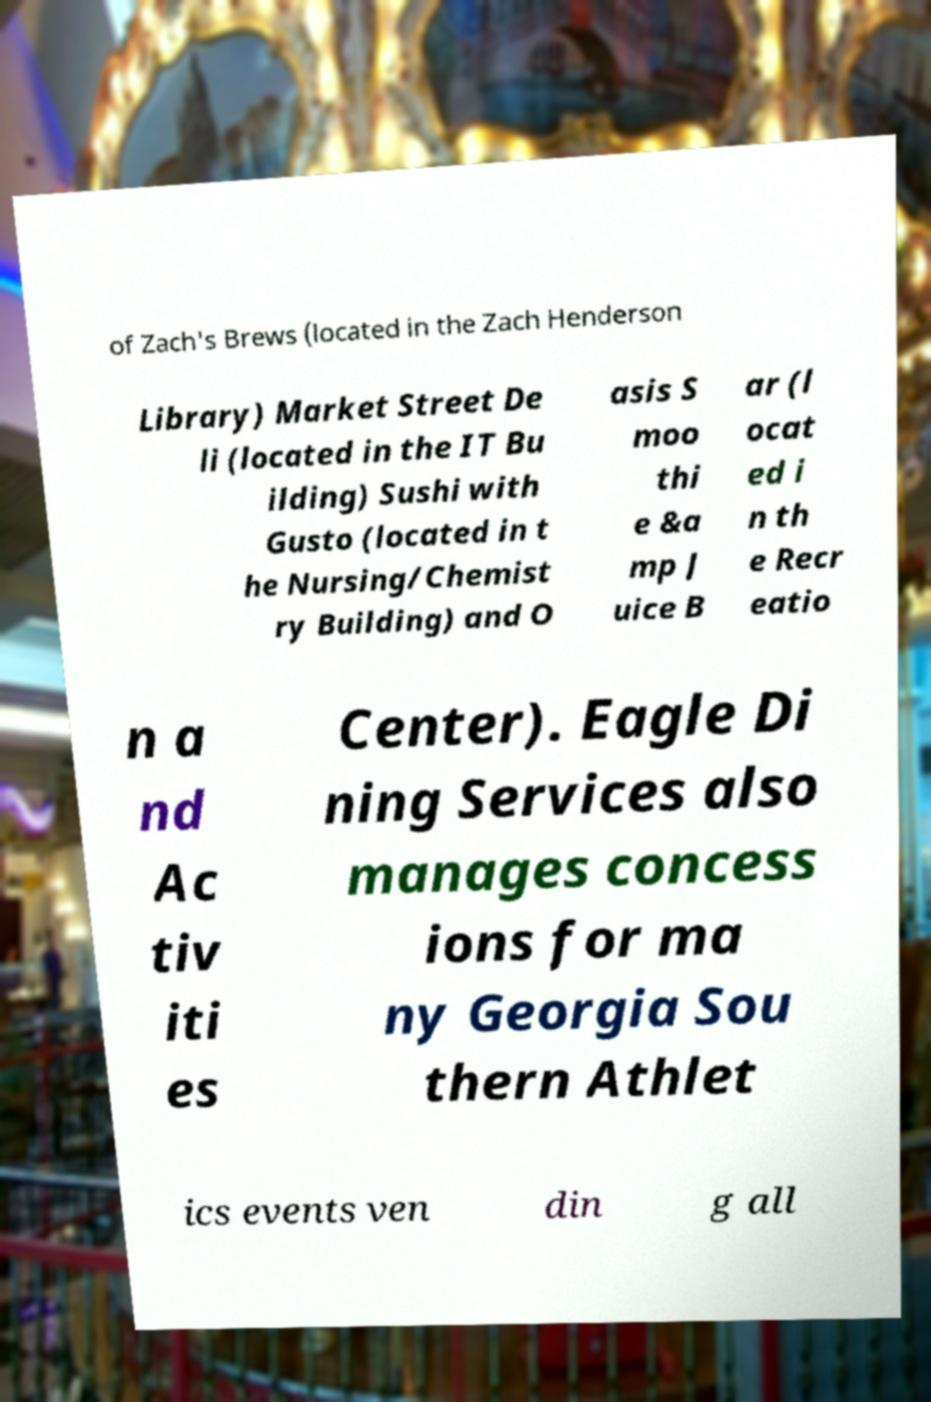Could you assist in decoding the text presented in this image and type it out clearly? of Zach's Brews (located in the Zach Henderson Library) Market Street De li (located in the IT Bu ilding) Sushi with Gusto (located in t he Nursing/Chemist ry Building) and O asis S moo thi e &a mp J uice B ar (l ocat ed i n th e Recr eatio n a nd Ac tiv iti es Center). Eagle Di ning Services also manages concess ions for ma ny Georgia Sou thern Athlet ics events ven din g all 